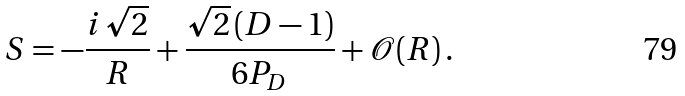Convert formula to latex. <formula><loc_0><loc_0><loc_500><loc_500>S = - \frac { i \, \sqrt { 2 } } { R } + \frac { \sqrt { 2 } \, ( D - 1 ) } { 6 P _ { D } } + \mathcal { O } ( R ) \, .</formula> 